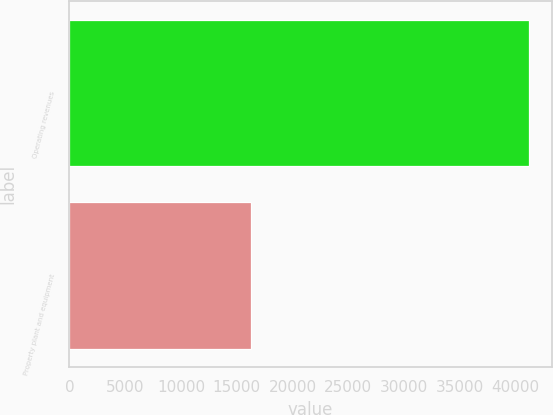<chart> <loc_0><loc_0><loc_500><loc_500><bar_chart><fcel>Operating revenues<fcel>Property plant and equipment<nl><fcel>41165<fcel>16271<nl></chart> 